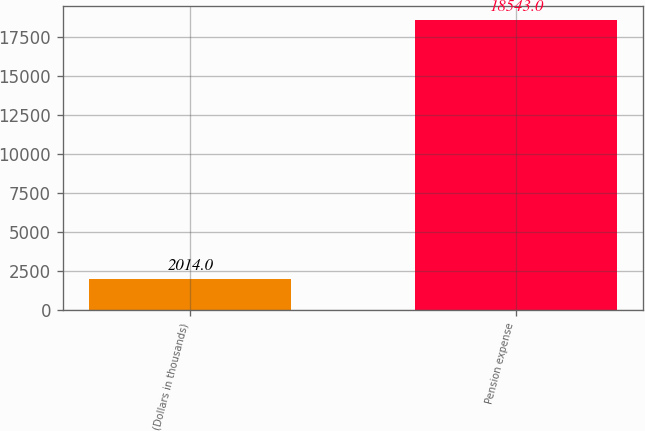Convert chart. <chart><loc_0><loc_0><loc_500><loc_500><bar_chart><fcel>(Dollars in thousands)<fcel>Pension expense<nl><fcel>2014<fcel>18543<nl></chart> 